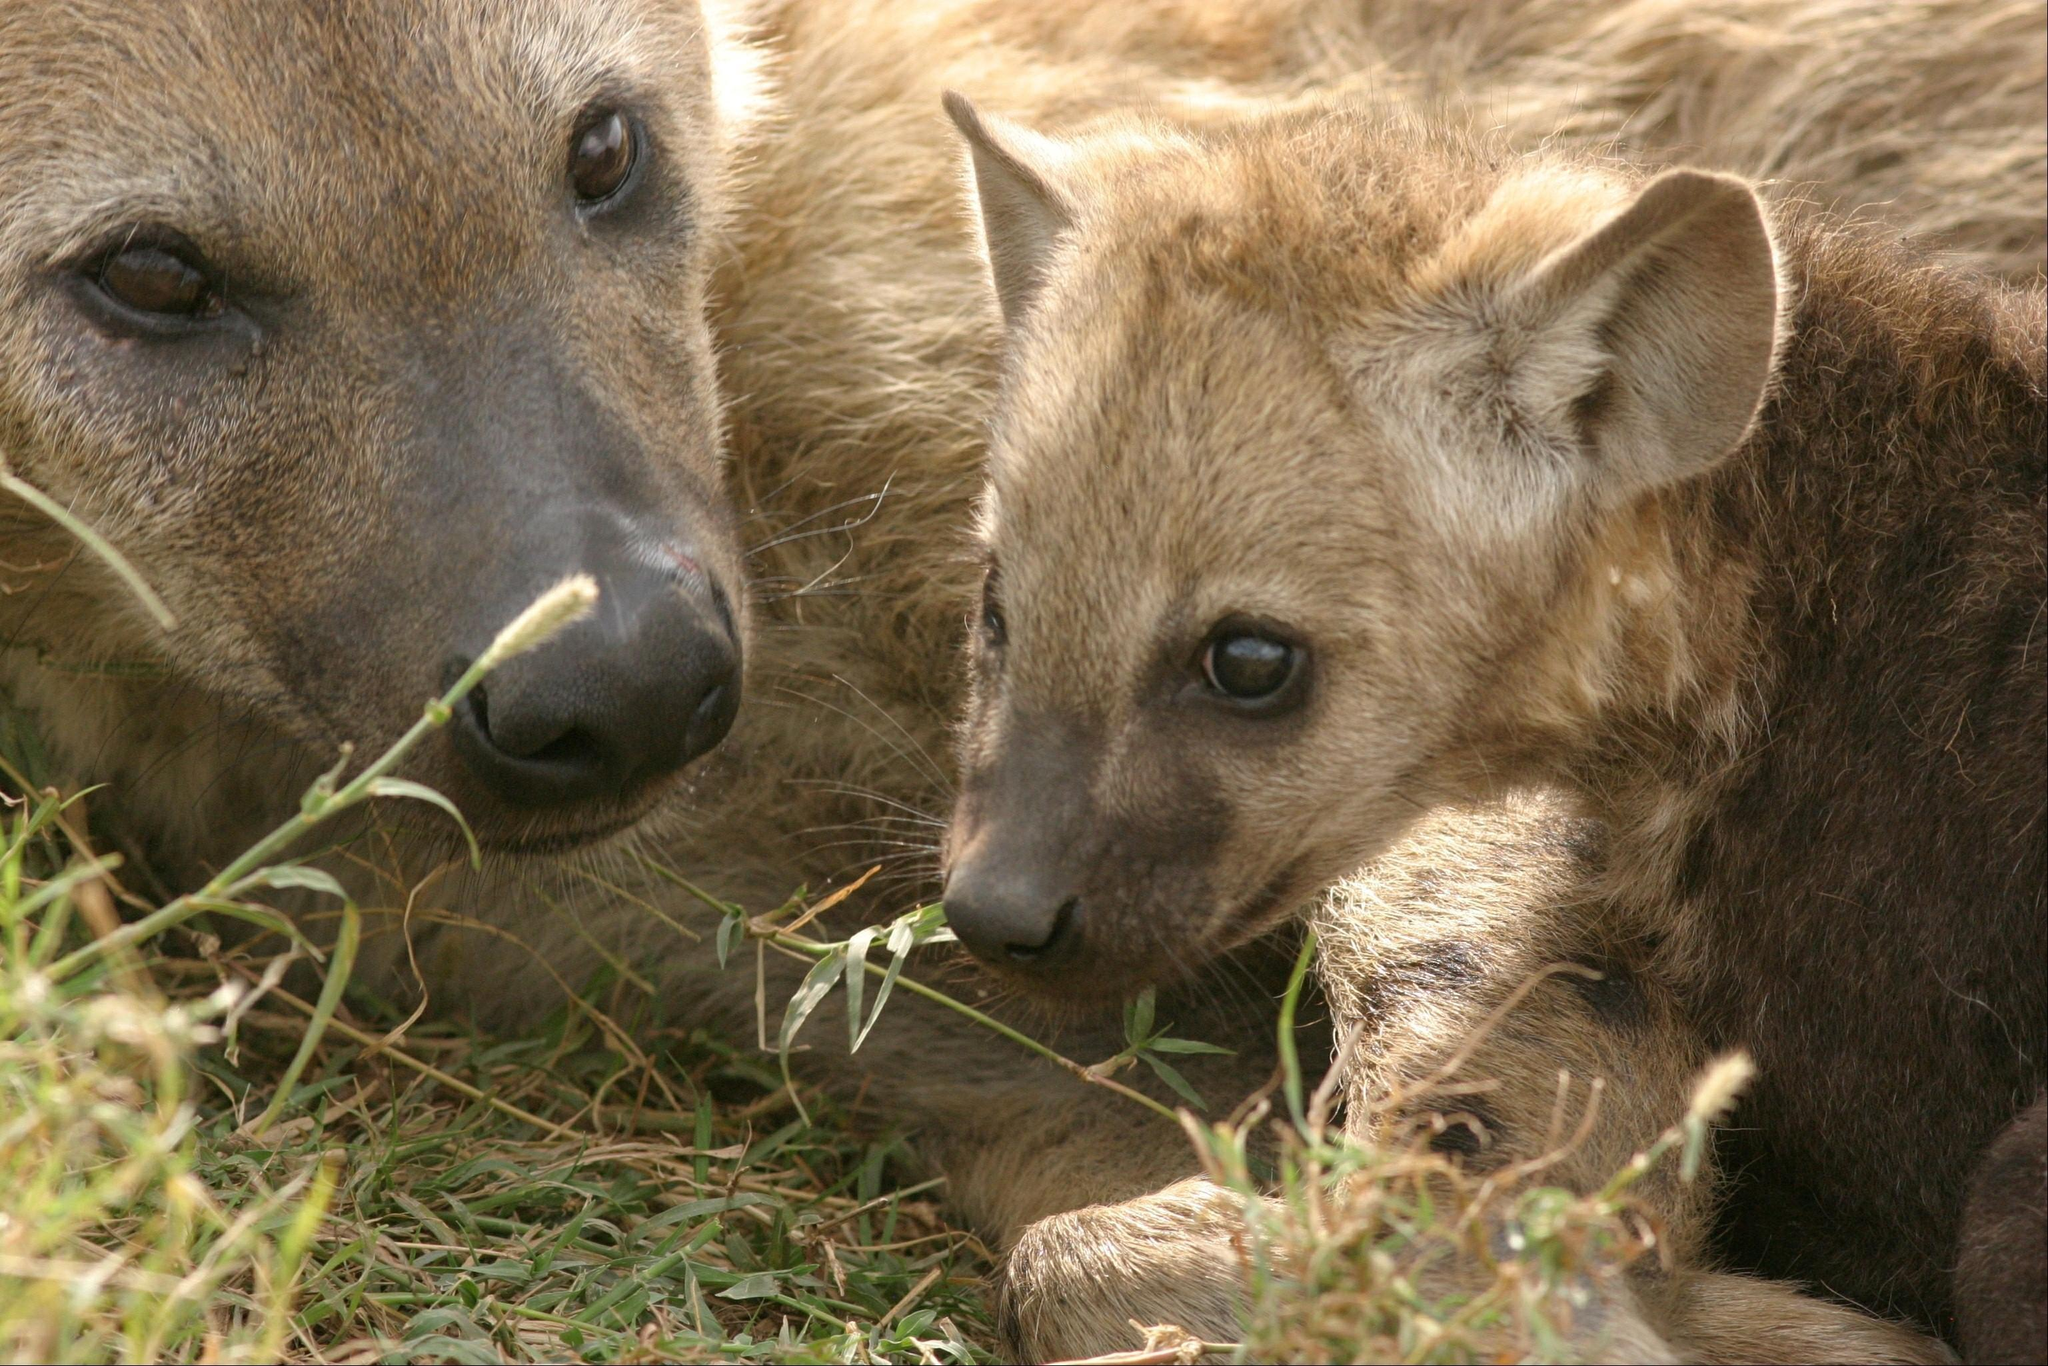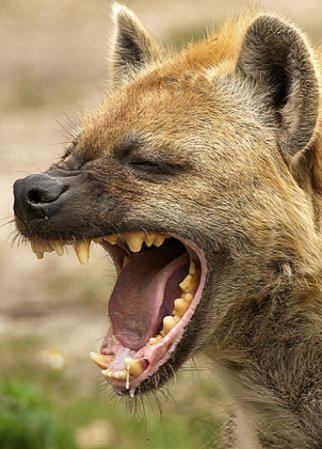The first image is the image on the left, the second image is the image on the right. Examine the images to the left and right. Is the description "Some teeth are visible in one of the images." accurate? Answer yes or no. Yes. 